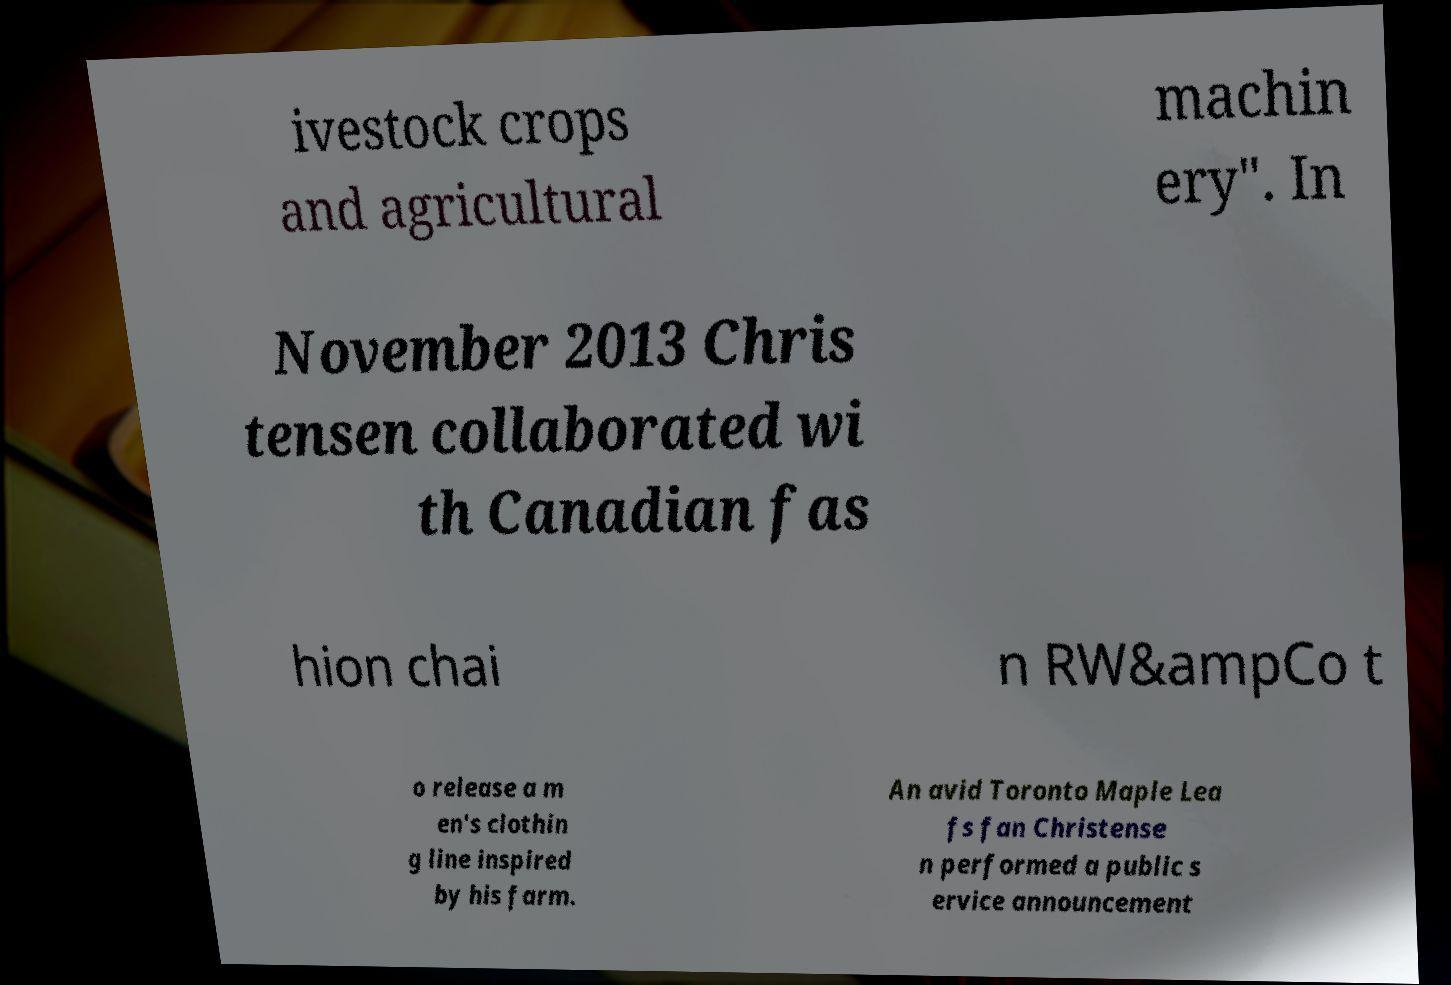For documentation purposes, I need the text within this image transcribed. Could you provide that? ivestock crops and agricultural machin ery". In November 2013 Chris tensen collaborated wi th Canadian fas hion chai n RW&ampCo t o release a m en's clothin g line inspired by his farm. An avid Toronto Maple Lea fs fan Christense n performed a public s ervice announcement 